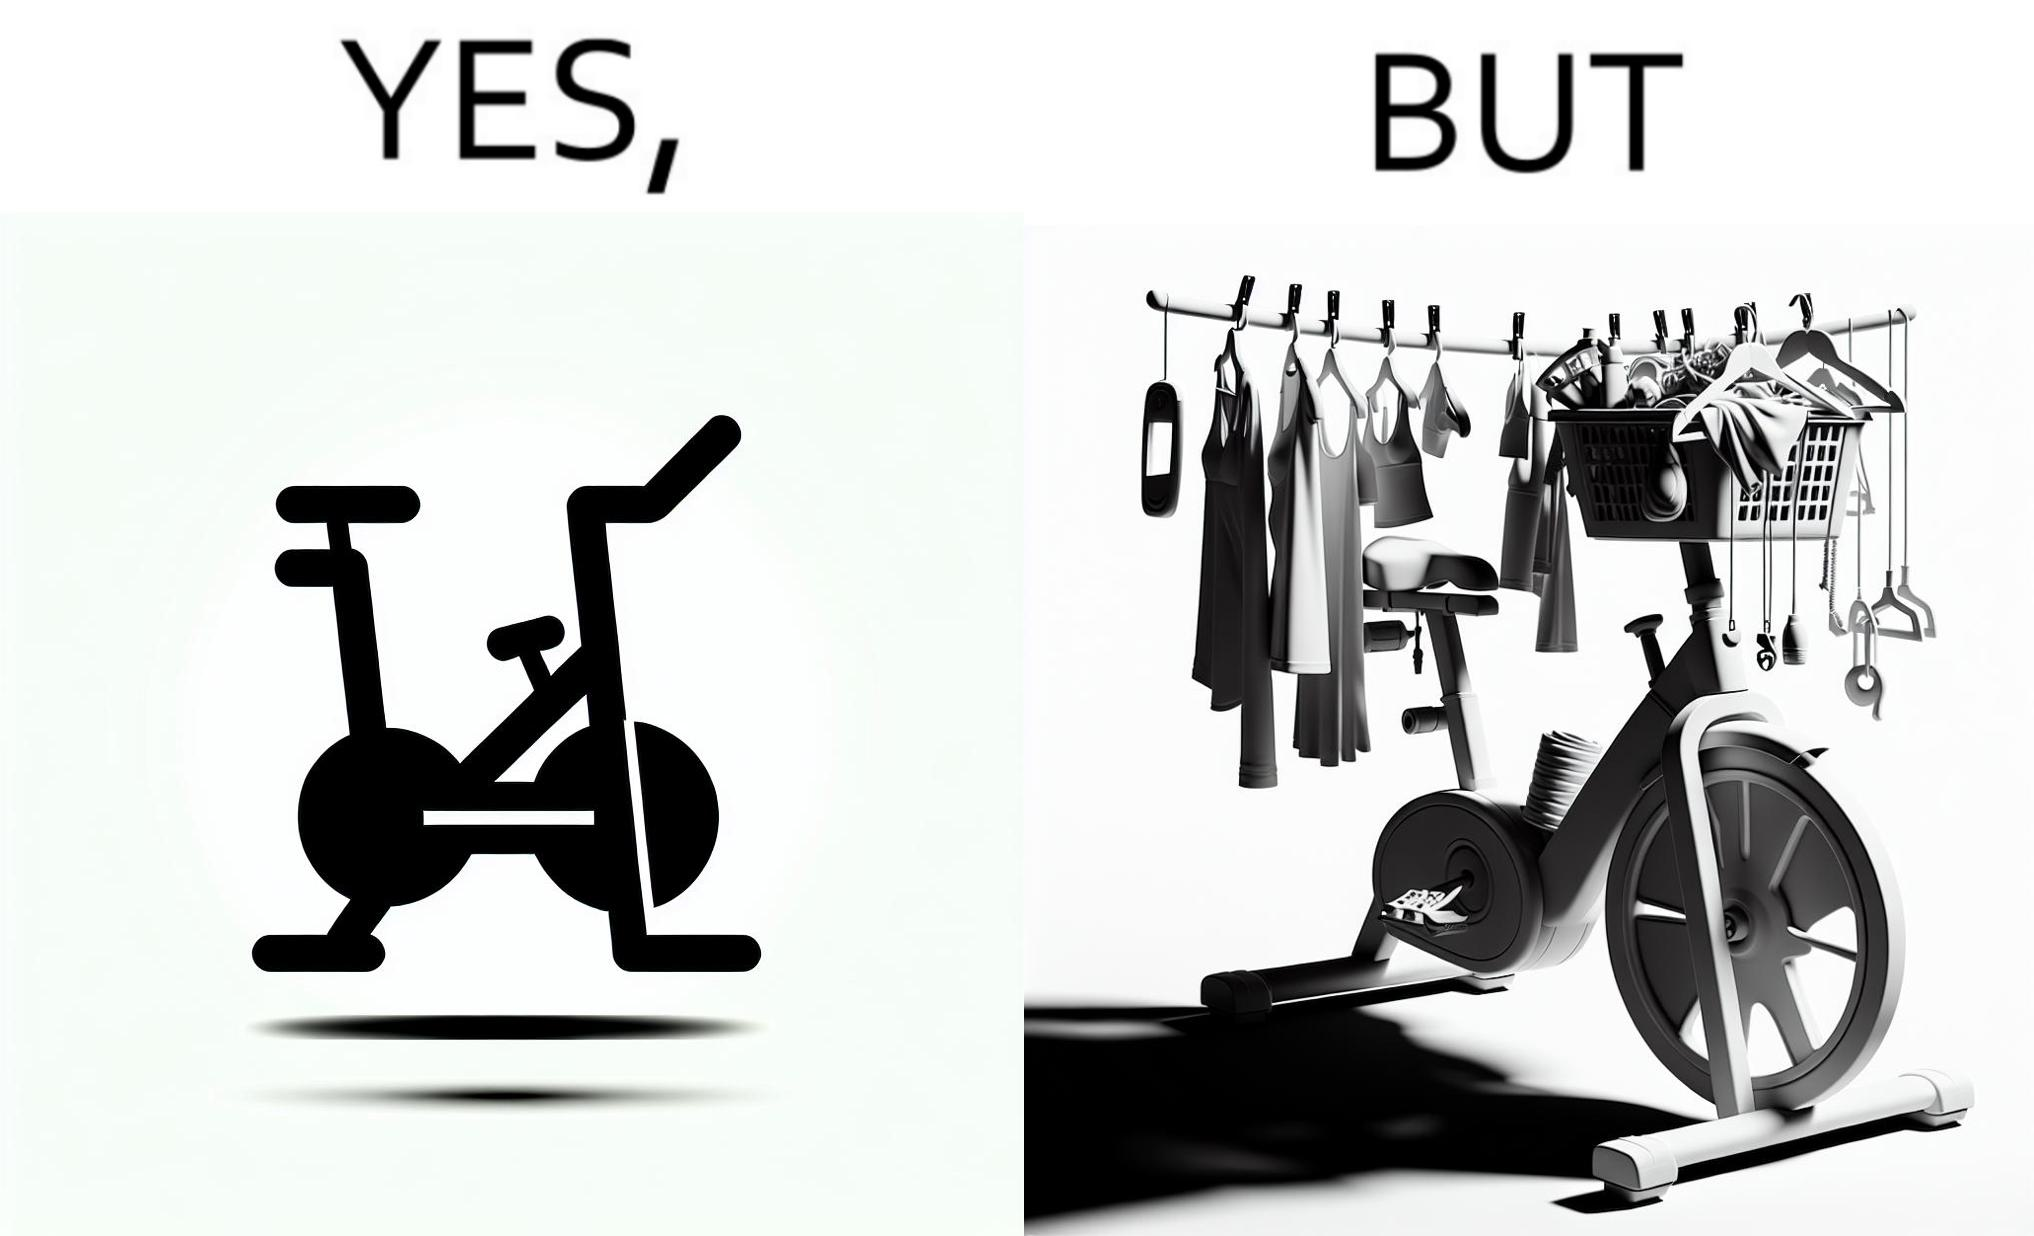Describe the contrast between the left and right parts of this image. In the left part of the image: An exercise bike In the right part of the image: An exercise bike being used to hang clothes and other items 